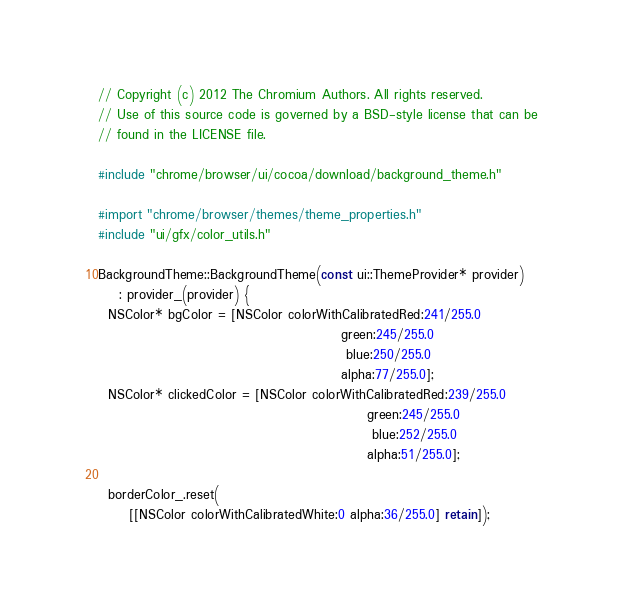<code> <loc_0><loc_0><loc_500><loc_500><_ObjectiveC_>// Copyright (c) 2012 The Chromium Authors. All rights reserved.
// Use of this source code is governed by a BSD-style license that can be
// found in the LICENSE file.

#include "chrome/browser/ui/cocoa/download/background_theme.h"

#import "chrome/browser/themes/theme_properties.h"
#include "ui/gfx/color_utils.h"

BackgroundTheme::BackgroundTheme(const ui::ThemeProvider* provider)
    : provider_(provider) {
  NSColor* bgColor = [NSColor colorWithCalibratedRed:241/255.0
                                               green:245/255.0
                                                blue:250/255.0
                                               alpha:77/255.0];
  NSColor* clickedColor = [NSColor colorWithCalibratedRed:239/255.0
                                                    green:245/255.0
                                                     blue:252/255.0
                                                    alpha:51/255.0];

  borderColor_.reset(
      [[NSColor colorWithCalibratedWhite:0 alpha:36/255.0] retain]);</code> 